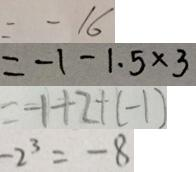<formula> <loc_0><loc_0><loc_500><loc_500>= - 1 6 
 = - 1 - 1 . 5 \times 3 
 = - 1 + 2 + ( - 1 ) 
 - 2 ^ { 3 } = - 8</formula> 